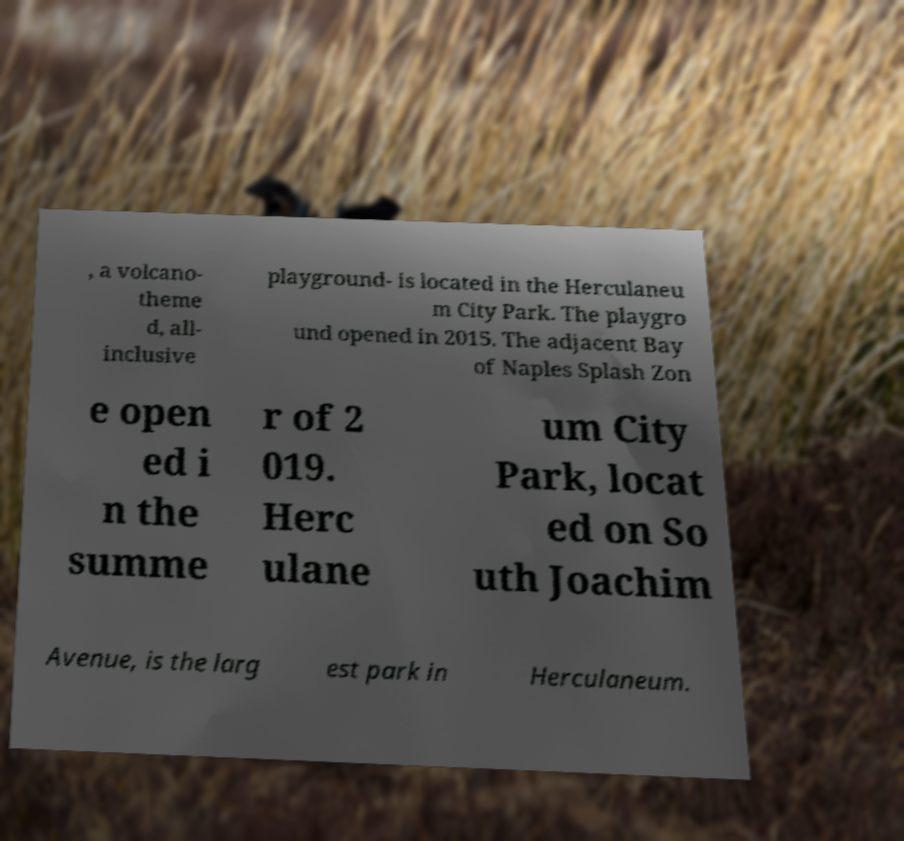For documentation purposes, I need the text within this image transcribed. Could you provide that? , a volcano- theme d, all- inclusive playground- is located in the Herculaneu m City Park. The playgro und opened in 2015. The adjacent Bay of Naples Splash Zon e open ed i n the summe r of 2 019. Herc ulane um City Park, locat ed on So uth Joachim Avenue, is the larg est park in Herculaneum. 